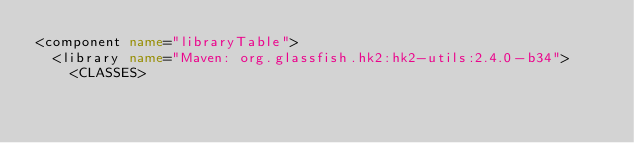Convert code to text. <code><loc_0><loc_0><loc_500><loc_500><_XML_><component name="libraryTable">
  <library name="Maven: org.glassfish.hk2:hk2-utils:2.4.0-b34">
    <CLASSES></code> 